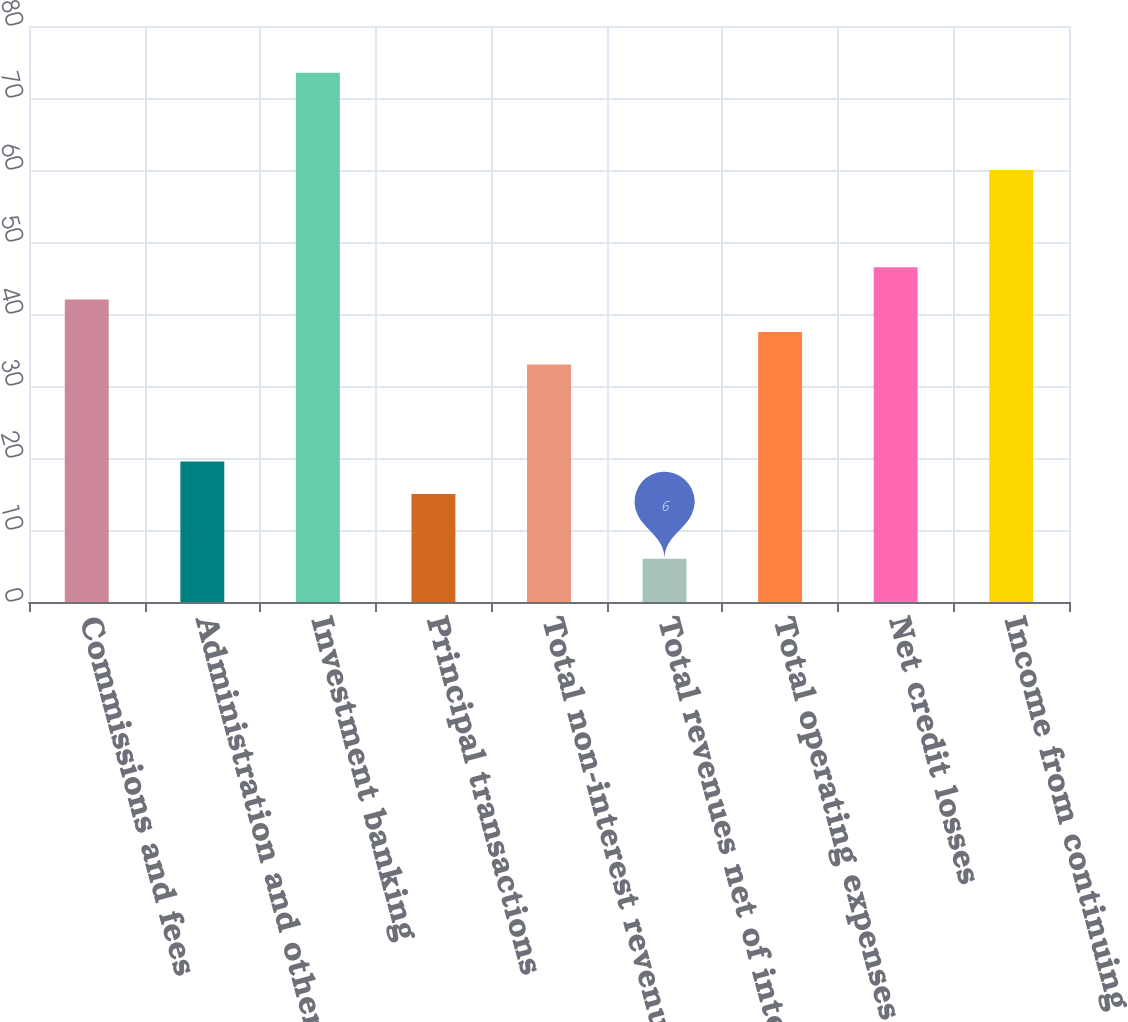<chart> <loc_0><loc_0><loc_500><loc_500><bar_chart><fcel>Commissions and fees<fcel>Administration and other<fcel>Investment banking<fcel>Principal transactions<fcel>Total non-interest revenue<fcel>Total revenues net of interest<fcel>Total operating expenses<fcel>Net credit losses<fcel>Income from continuing<nl><fcel>42<fcel>19.5<fcel>73.5<fcel>15<fcel>33<fcel>6<fcel>37.5<fcel>46.5<fcel>60<nl></chart> 